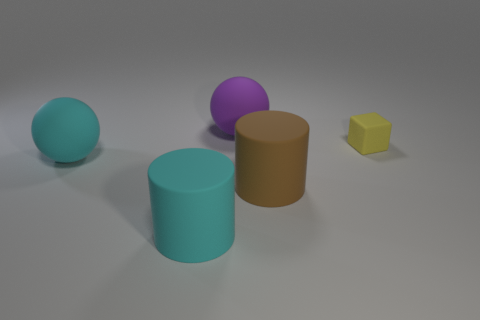Add 4 yellow rubber things. How many objects exist? 9 Subtract all blocks. How many objects are left? 4 Subtract 0 green cubes. How many objects are left? 5 Subtract all brown cylinders. Subtract all yellow matte objects. How many objects are left? 3 Add 5 tiny yellow rubber objects. How many tiny yellow rubber objects are left? 6 Add 2 tiny cyan matte things. How many tiny cyan matte things exist? 2 